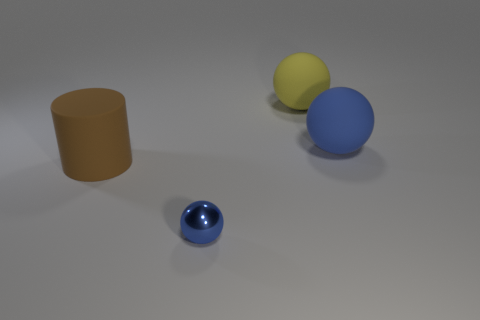Add 4 big balls. How many objects exist? 8 Subtract all balls. How many objects are left? 1 Subtract 0 blue cylinders. How many objects are left? 4 Subtract all big yellow metallic cylinders. Subtract all yellow matte objects. How many objects are left? 3 Add 3 large yellow things. How many large yellow things are left? 4 Add 1 small shiny objects. How many small shiny objects exist? 2 